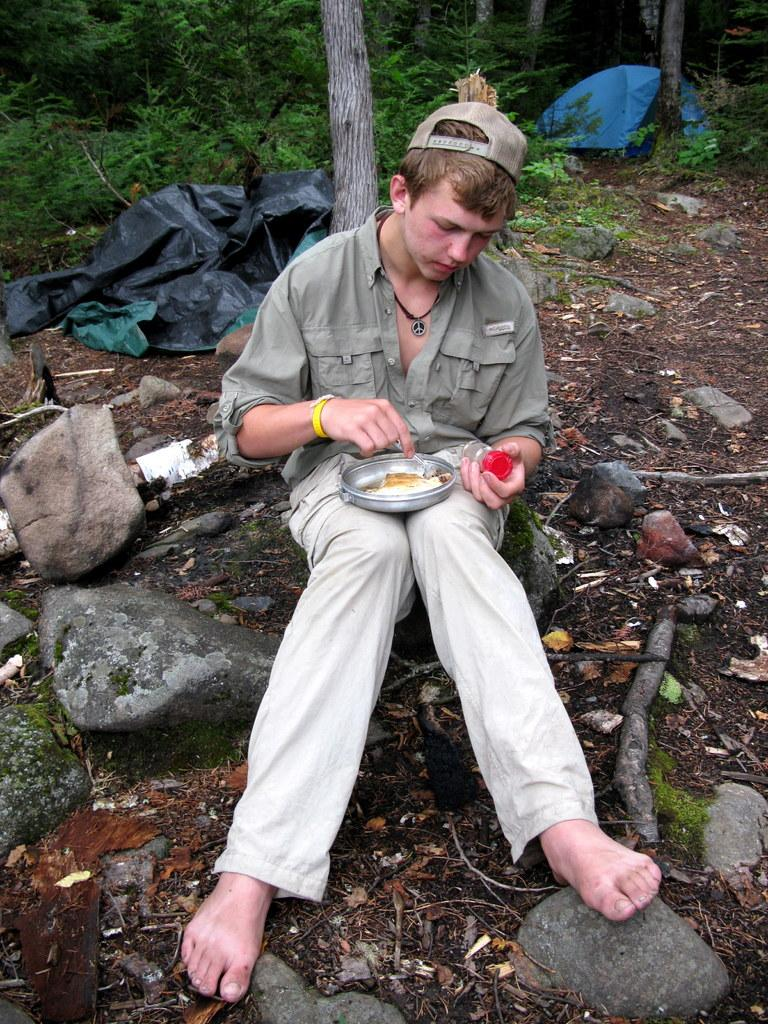What is the boy doing in the image? The boy is sitting on the stones and eating something from a box. What else is the boy holding in the image? The boy is holding a jar. What can be seen in the background of the image? There are trees behind the boy. What type of material is covering the ground in the image? There are plastic covers visible. What type of powder is the boy using to enhance his performance in the image? There is no powder present in the image, and the boy is not performing any activity that would require enhancement. 